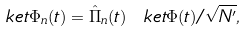<formula> <loc_0><loc_0><loc_500><loc_500>\ k e t { \Phi _ { n } ( t ) } = \hat { \Pi } _ { n } ( t ) \ k e t { \Phi ( t ) } / \sqrt { N ^ { \prime } } ,</formula> 